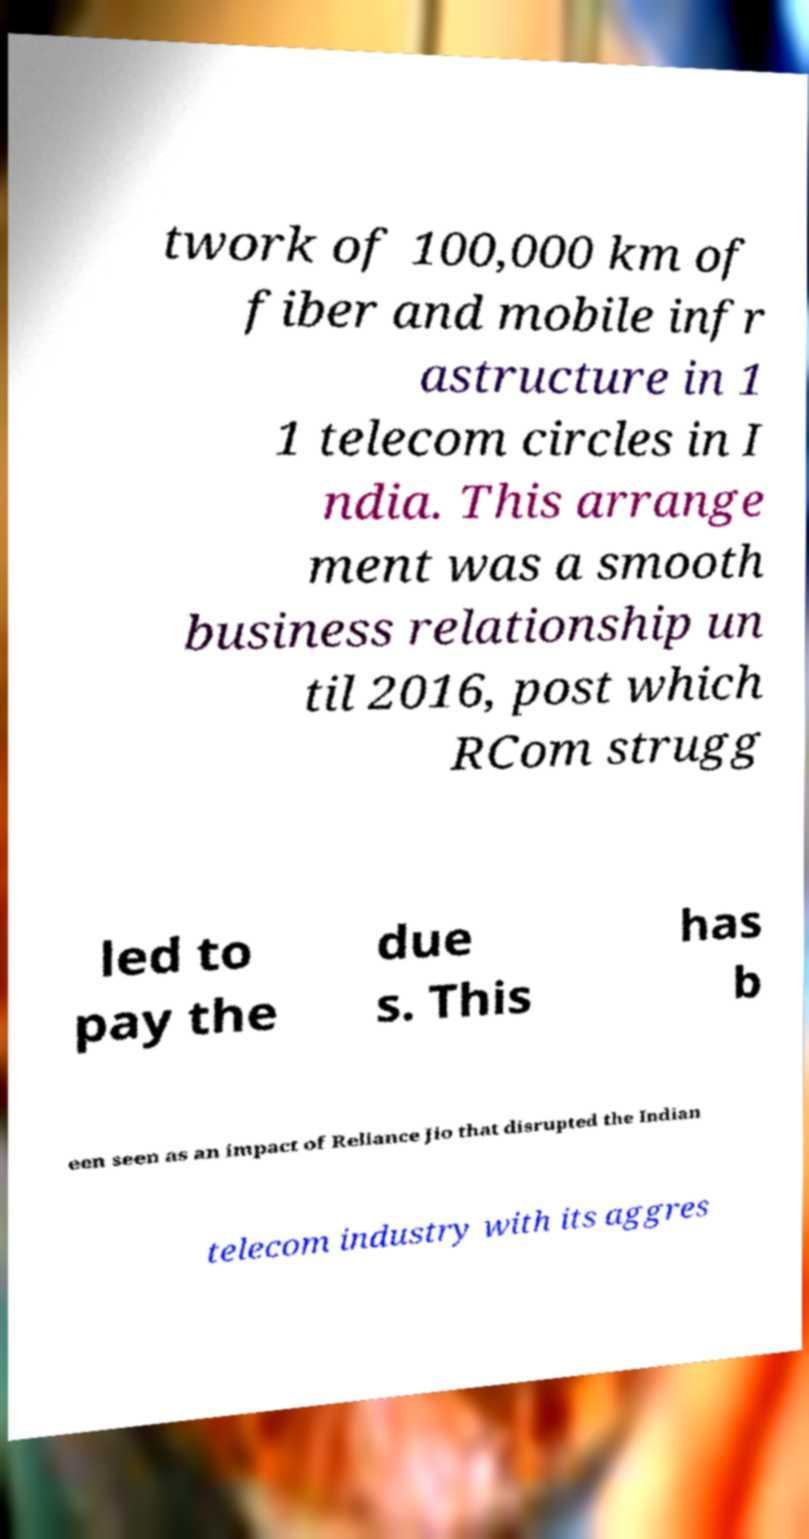Please identify and transcribe the text found in this image. twork of 100,000 km of fiber and mobile infr astructure in 1 1 telecom circles in I ndia. This arrange ment was a smooth business relationship un til 2016, post which RCom strugg led to pay the due s. This has b een seen as an impact of Reliance Jio that disrupted the Indian telecom industry with its aggres 